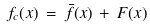<formula> <loc_0><loc_0><loc_500><loc_500>f _ { c } ( { x } ) \, = \, { \bar { f } } ( { x } ) \, + \, F ( { x } ) \ \\</formula> 